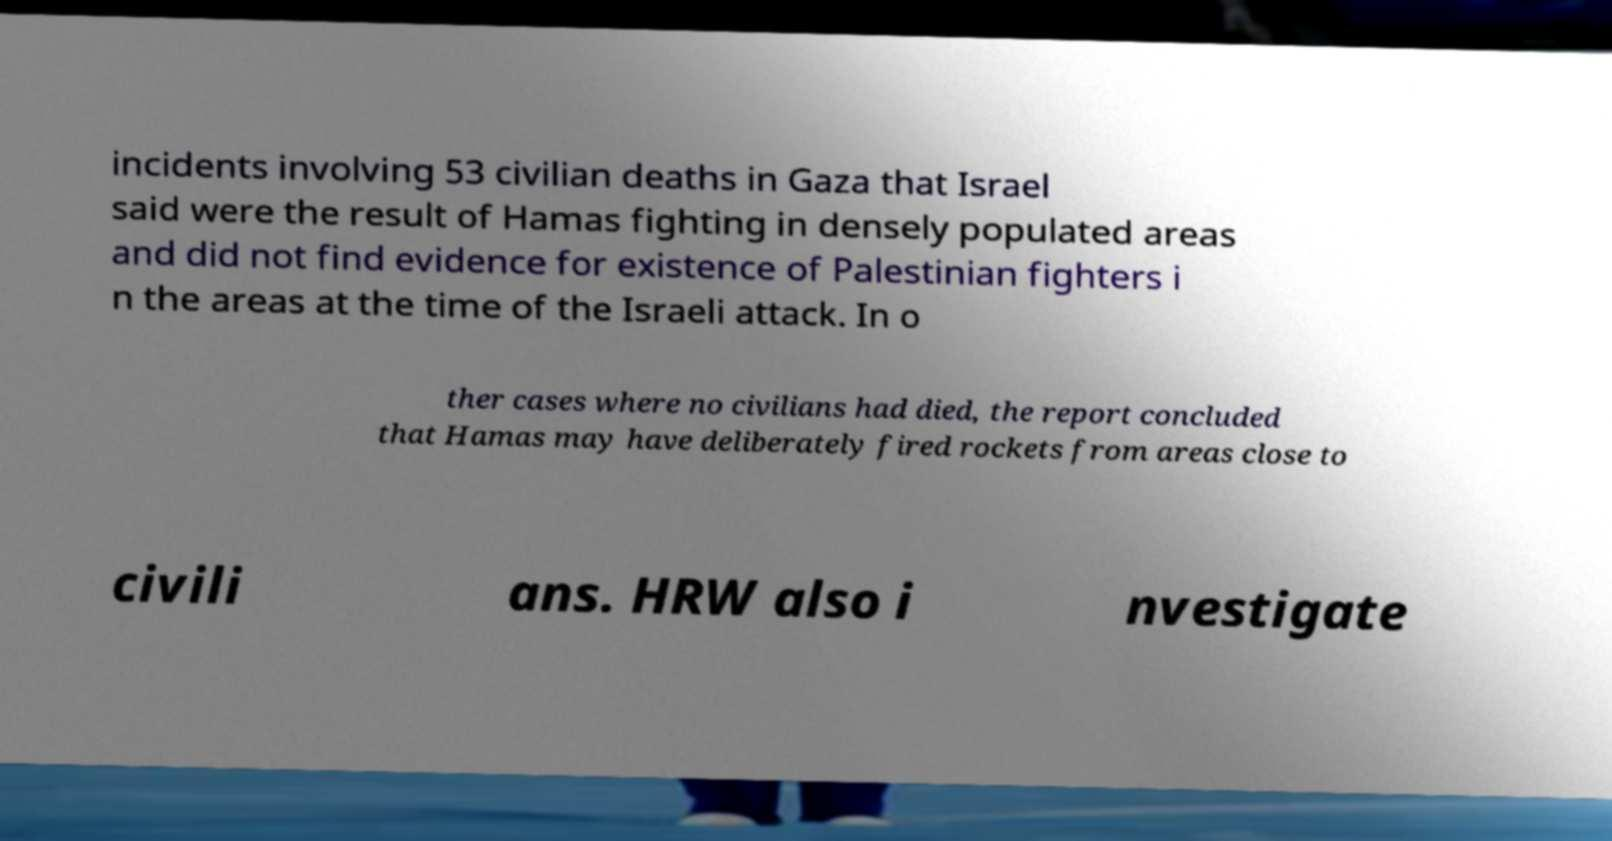Could you extract and type out the text from this image? incidents involving 53 civilian deaths in Gaza that Israel said were the result of Hamas fighting in densely populated areas and did not find evidence for existence of Palestinian fighters i n the areas at the time of the Israeli attack. In o ther cases where no civilians had died, the report concluded that Hamas may have deliberately fired rockets from areas close to civili ans. HRW also i nvestigate 